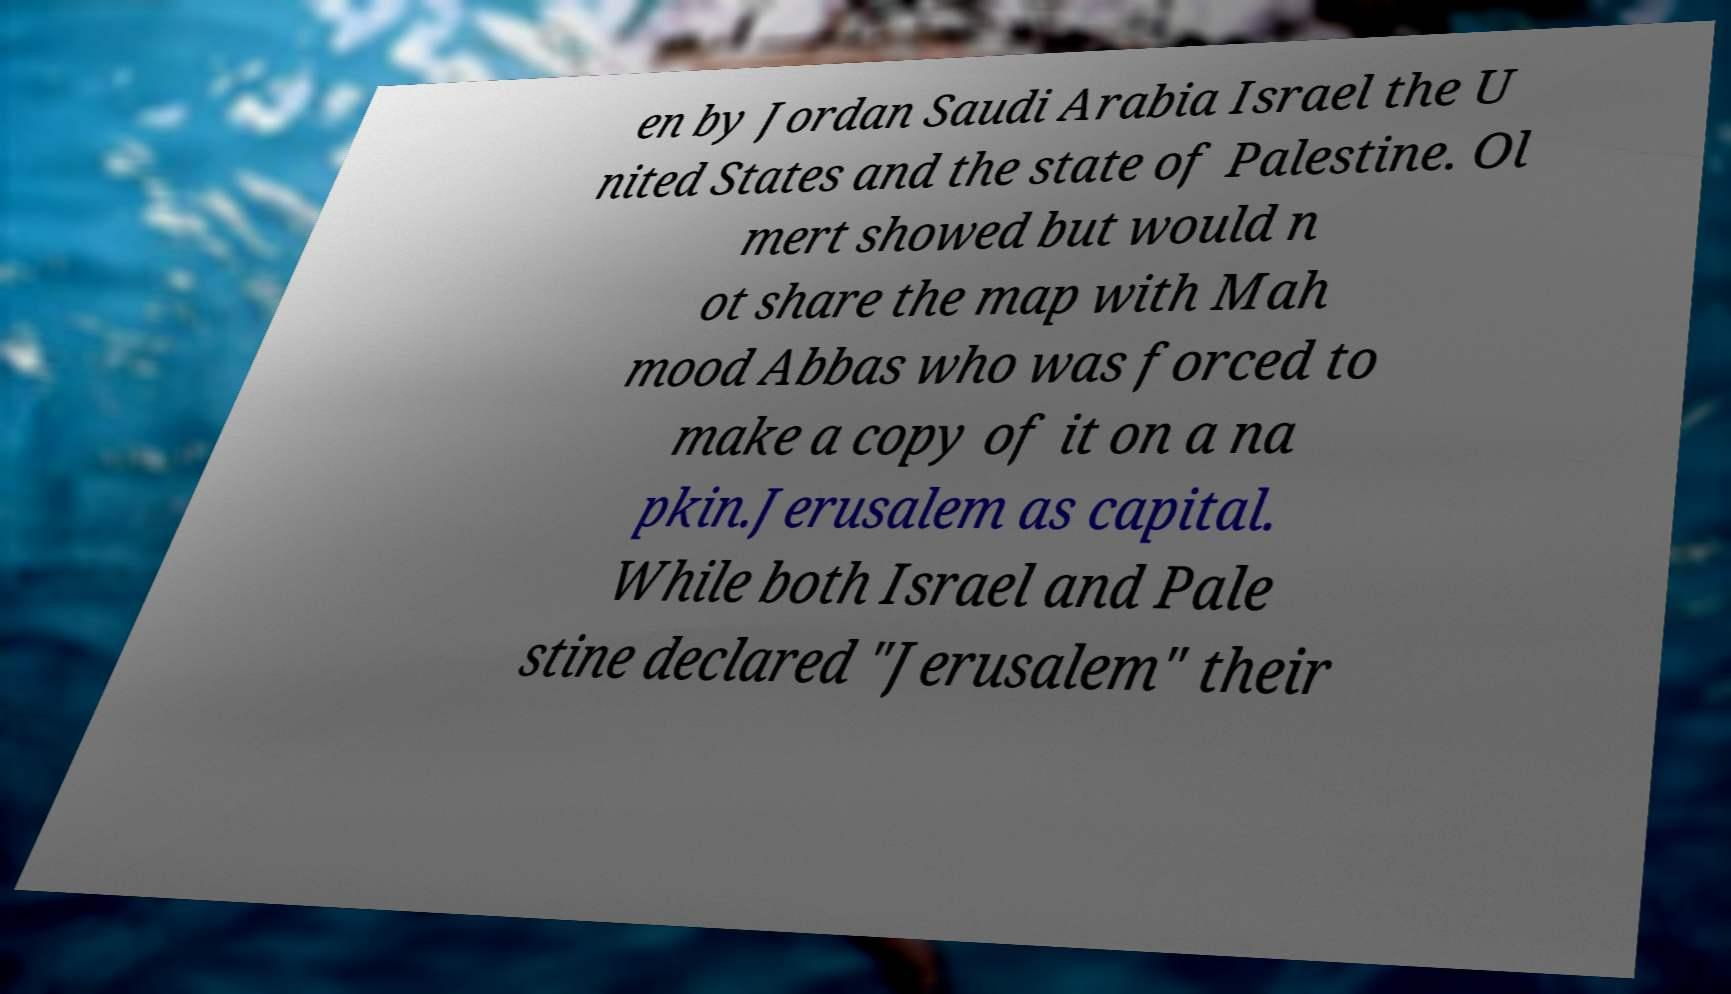Could you assist in decoding the text presented in this image and type it out clearly? en by Jordan Saudi Arabia Israel the U nited States and the state of Palestine. Ol mert showed but would n ot share the map with Mah mood Abbas who was forced to make a copy of it on a na pkin.Jerusalem as capital. While both Israel and Pale stine declared "Jerusalem" their 